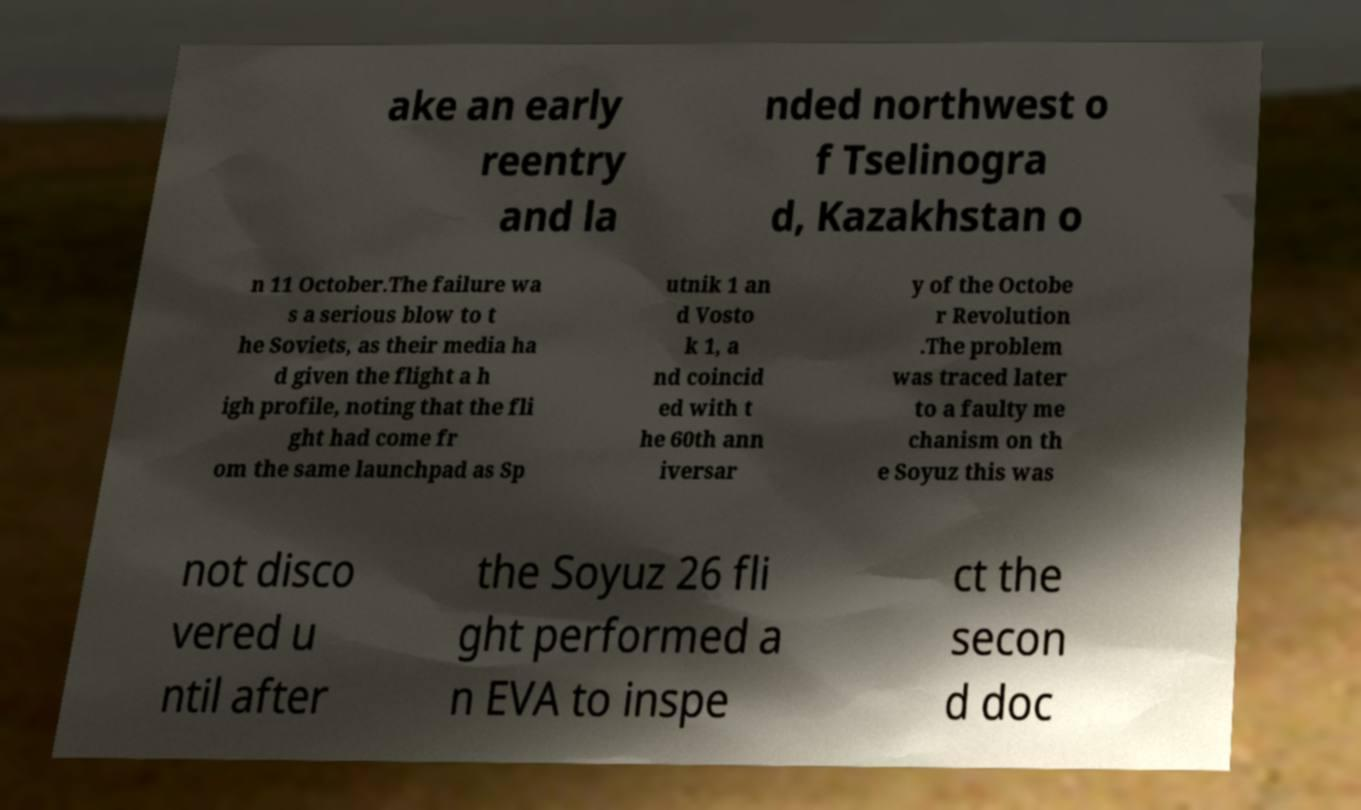Could you assist in decoding the text presented in this image and type it out clearly? ake an early reentry and la nded northwest o f Tselinogra d, Kazakhstan o n 11 October.The failure wa s a serious blow to t he Soviets, as their media ha d given the flight a h igh profile, noting that the fli ght had come fr om the same launchpad as Sp utnik 1 an d Vosto k 1, a nd coincid ed with t he 60th ann iversar y of the Octobe r Revolution .The problem was traced later to a faulty me chanism on th e Soyuz this was not disco vered u ntil after the Soyuz 26 fli ght performed a n EVA to inspe ct the secon d doc 